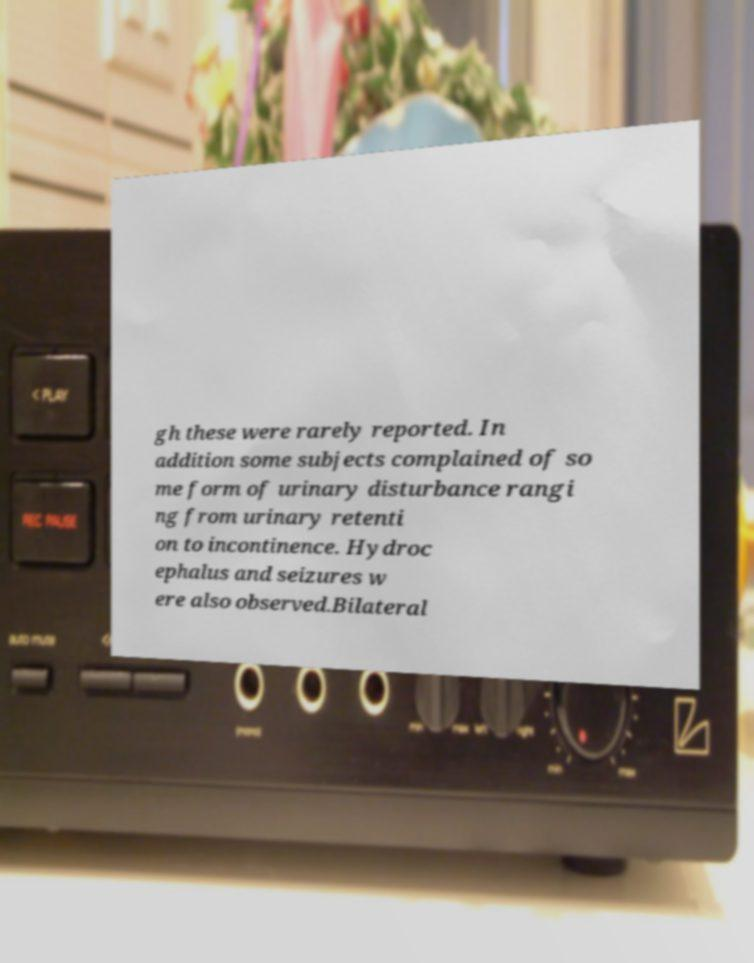Can you read and provide the text displayed in the image?This photo seems to have some interesting text. Can you extract and type it out for me? gh these were rarely reported. In addition some subjects complained of so me form of urinary disturbance rangi ng from urinary retenti on to incontinence. Hydroc ephalus and seizures w ere also observed.Bilateral 